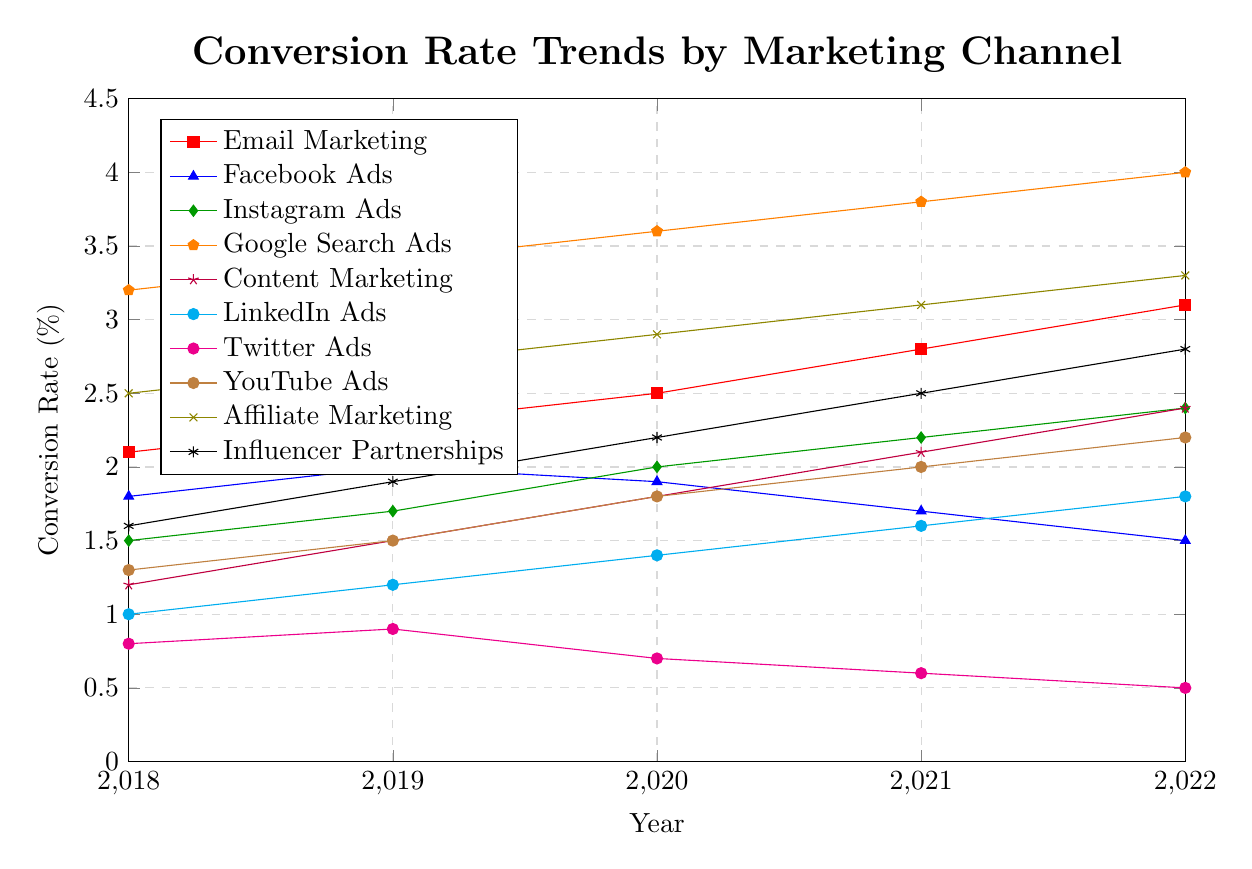Which marketing channel had the highest conversion rate in 2022? By looking at the figure, we find the highest point on the y-axis for the year 2022, which corresponds to the line for Google Search Ads.
Answer: Google Search Ads What is the trend of conversion rates for Twitter Ads from 2018 to 2022? Observing the line for Twitter Ads, the conversion rate consistently decreased from 0.8% in 2018 to 0.5% in 2022.
Answer: Decreasing Which two marketing channels saw an increase in conversion rates every year from 2018 to 2022? Identifying the lines that show a consistent upward trend with no dips, we see that Email Marketing and Influencer Partnerships both increased every year.
Answer: Email Marketing, Influencer Partnerships Between 2019 and 2020, which marketing channel saw the largest increase in conversion rate? By comparing the differences between 2019 and 2020 for each channel, we see that Instagram Ads increased from 1.7% to 2.0%, which is the largest jump (0.3%).
Answer: Instagram Ads What is the average conversion rate for YouTube Ads over the five years? Summing the conversion rates for YouTube Ads from 2018 to 2022 (1.3, 1.5, 1.8, 2.0, 2.2) and dividing by 5, the average is (1.3 + 1.5 + 1.8 + 2.0 + 2.2)/5 = 1.76%.
Answer: 1.76% Which marketing channel had the least year-to-year variability in conversion rates? We identify the channel with the smallest changes between years. Google Search Ads had consistently small, incremental increases (0.2 each year).
Answer: Google Search Ads How did the conversion rates for Facebook Ads and Twitter Ads compare in 2022? By assessing the points for both channels in 2022, Facebook Ads had a conversion rate of 1.5% and Twitter Ads had 0.5%. Facebook Ads was higher.
Answer: Facebook Ads higher What is the difference in conversion rates between Content Marketing (Blog) and LinkedIn Ads in 2022? Determining the conversion rates in 2022, Content Marketing had 2.4% and LinkedIn Ads had 1.8%. The difference is 2.4% - 1.8% = 0.6%.
Answer: 0.6% Which channel had a conversion rate equal to 2.0% in 2020? By looking at the data points for 2020, both Instagram Ads and YouTube Ads intersect the 2.0% line.
Answer: Instagram Ads, YouTube Ads What is the total increase in conversion rate for Email Marketing from 2018 to 2022? Calculating the difference between the conversion rates in 2022 and 2018 for Email Marketing, we get 3.1% - 2.1% = 1.0%.
Answer: 1.0% 